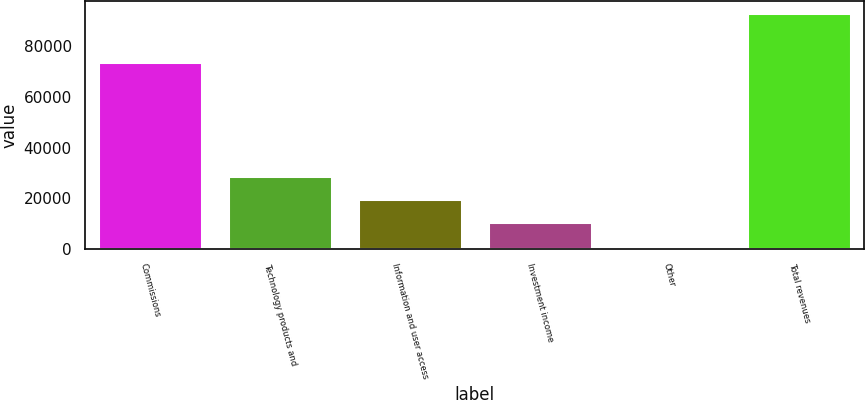<chart> <loc_0><loc_0><loc_500><loc_500><bar_chart><fcel>Commissions<fcel>Technology products and<fcel>Information and user access<fcel>Investment income<fcel>Other<fcel>Total revenues<nl><fcel>73528<fcel>28974.8<fcel>19816.2<fcel>10657.6<fcel>1499<fcel>93085<nl></chart> 